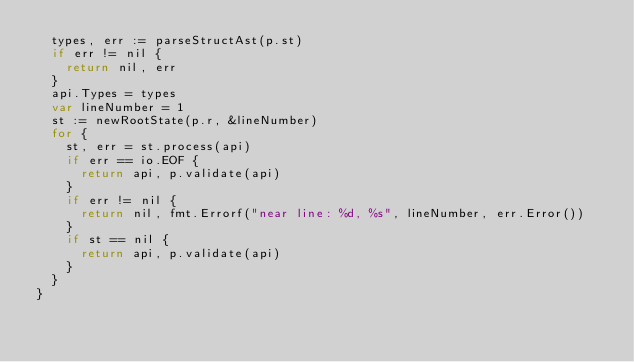<code> <loc_0><loc_0><loc_500><loc_500><_Go_>	types, err := parseStructAst(p.st)
	if err != nil {
		return nil, err
	}
	api.Types = types
	var lineNumber = 1
	st := newRootState(p.r, &lineNumber)
	for {
		st, err = st.process(api)
		if err == io.EOF {
			return api, p.validate(api)
		}
		if err != nil {
			return nil, fmt.Errorf("near line: %d, %s", lineNumber, err.Error())
		}
		if st == nil {
			return api, p.validate(api)
		}
	}
}
</code> 